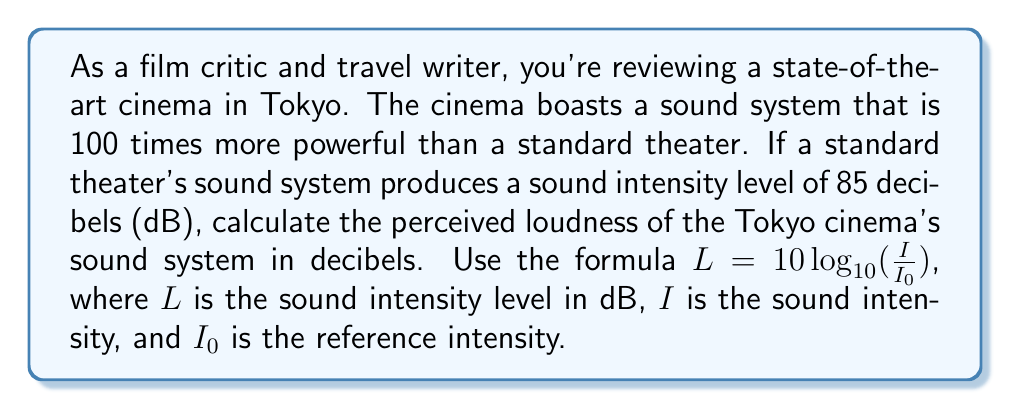Teach me how to tackle this problem. To solve this problem, we'll use the logarithmic relationship between sound intensity and decibels. Let's break it down step-by-step:

1) We're given that the new system is 100 times more powerful than the standard system. This means the intensity $I$ is 100 times greater than the standard system's intensity.

2) We know the standard system produces 85 dB. Let's call the standard system's intensity $I_1$ and the new system's intensity $I_2$.

3) For the standard system:
   $$85 = 10 \log_{10}(\frac{I_1}{I_0})$$

4) For the new system:
   $$L_2 = 10 \log_{10}(\frac{I_2}{I_0})$$

5) We know that $I_2 = 100I_1$, so we can substitute this into the equation for $L_2$:
   $$L_2 = 10 \log_{10}(\frac{100I_1}{I_0})$$

6) Using the logarithm property $\log_a(xy) = \log_a(x) + \log_a(y)$, we can split this:
   $$L_2 = 10 \log_{10}(100) + 10 \log_{10}(\frac{I_1}{I_0})$$

7) We know that $10 \log_{10}(\frac{I_1}{I_0}) = 85$ from step 3, so:
   $$L_2 = 10 \log_{10}(100) + 85$$

8) $\log_{10}(100) = 2$, so:
   $$L_2 = 10(2) + 85 = 20 + 85 = 105$$

Therefore, the perceived loudness of the Tokyo cinema's sound system is 105 dB.
Answer: 105 dB 